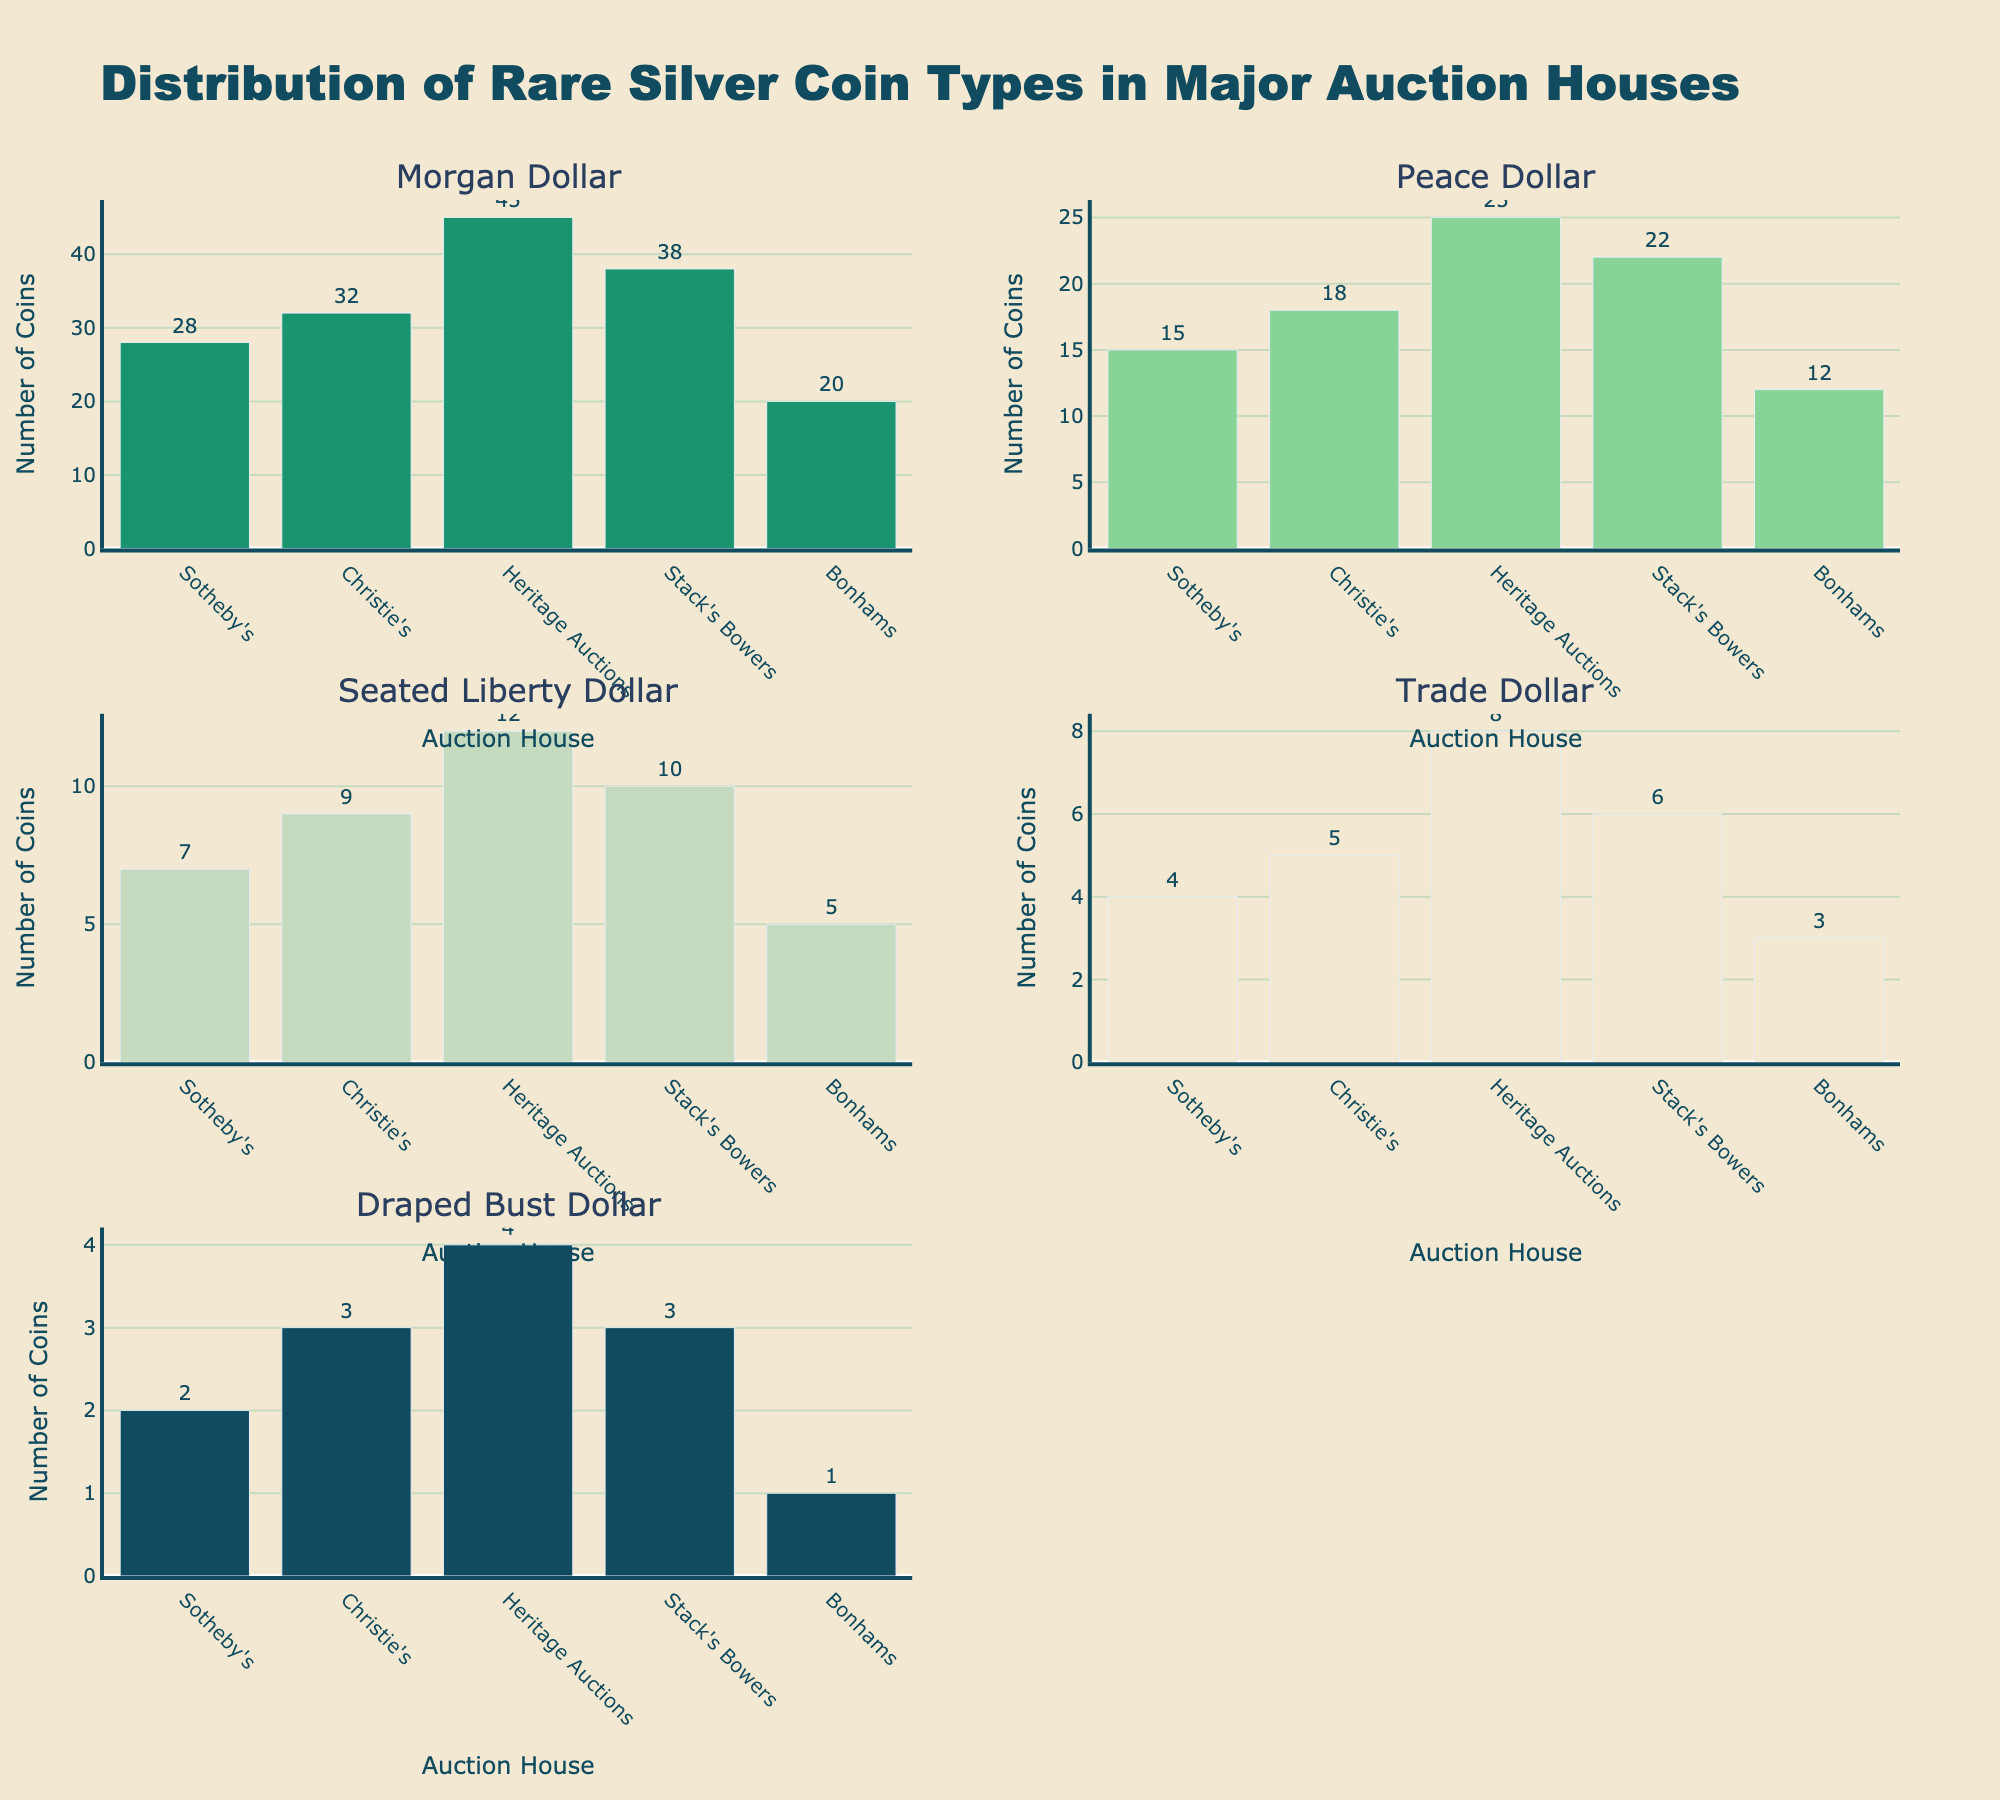what is the title of the figure? The title is located at the top of the subplot and provides an overview of the content. In this case, it reads "Distribution of Rare Silver Coin Types in Major Auction Houses".
Answer: Distribution of Rare Silver Coin Types in Major Auction Houses Which auction house has the highest count of Morgan Dollars? By examining the subplot for Morgan Dollars, look at the tallest bar. "Heritage Auctions" has the highest count which is 45.
Answer: Heritage Auctions How many more Peace Dollars does Christie's have compared to Bonhams? Look at the Peace Dollar subplot, find the count for Christie's (18) and Bonhams (12). Calculate the difference: 18 - 12 = 6.
Answer: 6 Which rare silver coin type has the smallest count at Stack's Bowers? Find the subplot for "Stack's Bowers" and identify the smallest bar. In this case, the Draped Bust Dollar has the smallest count, which is 3.
Answer: Draped Bust Dollar What is the total number of Seated Liberty Dollars across all auction houses? Sum the values for Seated Liberty Dollar from each auction house: 7 (Sotheby's) + 9 (Christie's) + 12 (Heritage Auctions) + 10 (Stack's Bowers) + 5 (Bonhams) = 43.
Answer: 43 Which auction house exhibits the least number of Trade Dollars? Locate the subplot for Trade Dollar and find which auction house has the smallest bar. Bonhams has the least number, which is 3.
Answer: Bonhams Compare the total number of Draped Bust Dollars with the total number of Seated Liberty Dollars. Which is greater, and by how much? Sum the values for Draped Bust Dollar: 2 (Sotheby's) + 3 (Christie's) + 4 (Heritage Auctions) + 3 (Stack's Bowers) + 1 (Bonhams) = 13. Compare it with the previously calculated total of Seated Liberty Dollar: 43. Calculate the difference: 43 - 13 = 30.
Answer: Seated Liberty Dollar by 30 What is the average number of Morgan Dollars across the five auction houses? Sum the values for Morgan Dollar: 28 (Sotheby's) + 32 (Christie's) + 45 (Heritage Auctions) + 38 (Stack's Bowers) + 20 (Bonhams) = 163. Divide by the number of auction houses, 163 / 5 = 32.6.
Answer: 32.6 Which two auction houses have the most similar number of Peace Dollars, and what are their counts? Look for two bars with close values in the Peace Dollar subplot. Sotheby's (15) and Bonhams (12) have the closest counts, differing by just 3.
Answer: Sotheby's (15) and Bonhams (12) Among the five auction houses, which coin type appears most frequently overall? Identify the coin type with the highest total count across all auction houses. Morgan Dollar has the highest frequency. Sum the values for Morgan Dollar: 28 + 32 + 45 + 38 + 20 = 163.
Answer: Morgan Dollar 